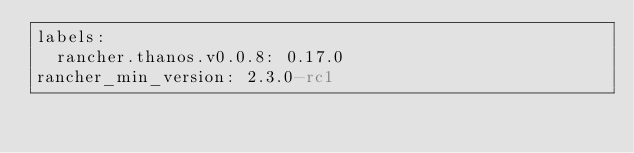<code> <loc_0><loc_0><loc_500><loc_500><_YAML_>labels:
  rancher.thanos.v0.0.8: 0.17.0
rancher_min_version: 2.3.0-rc1
</code> 